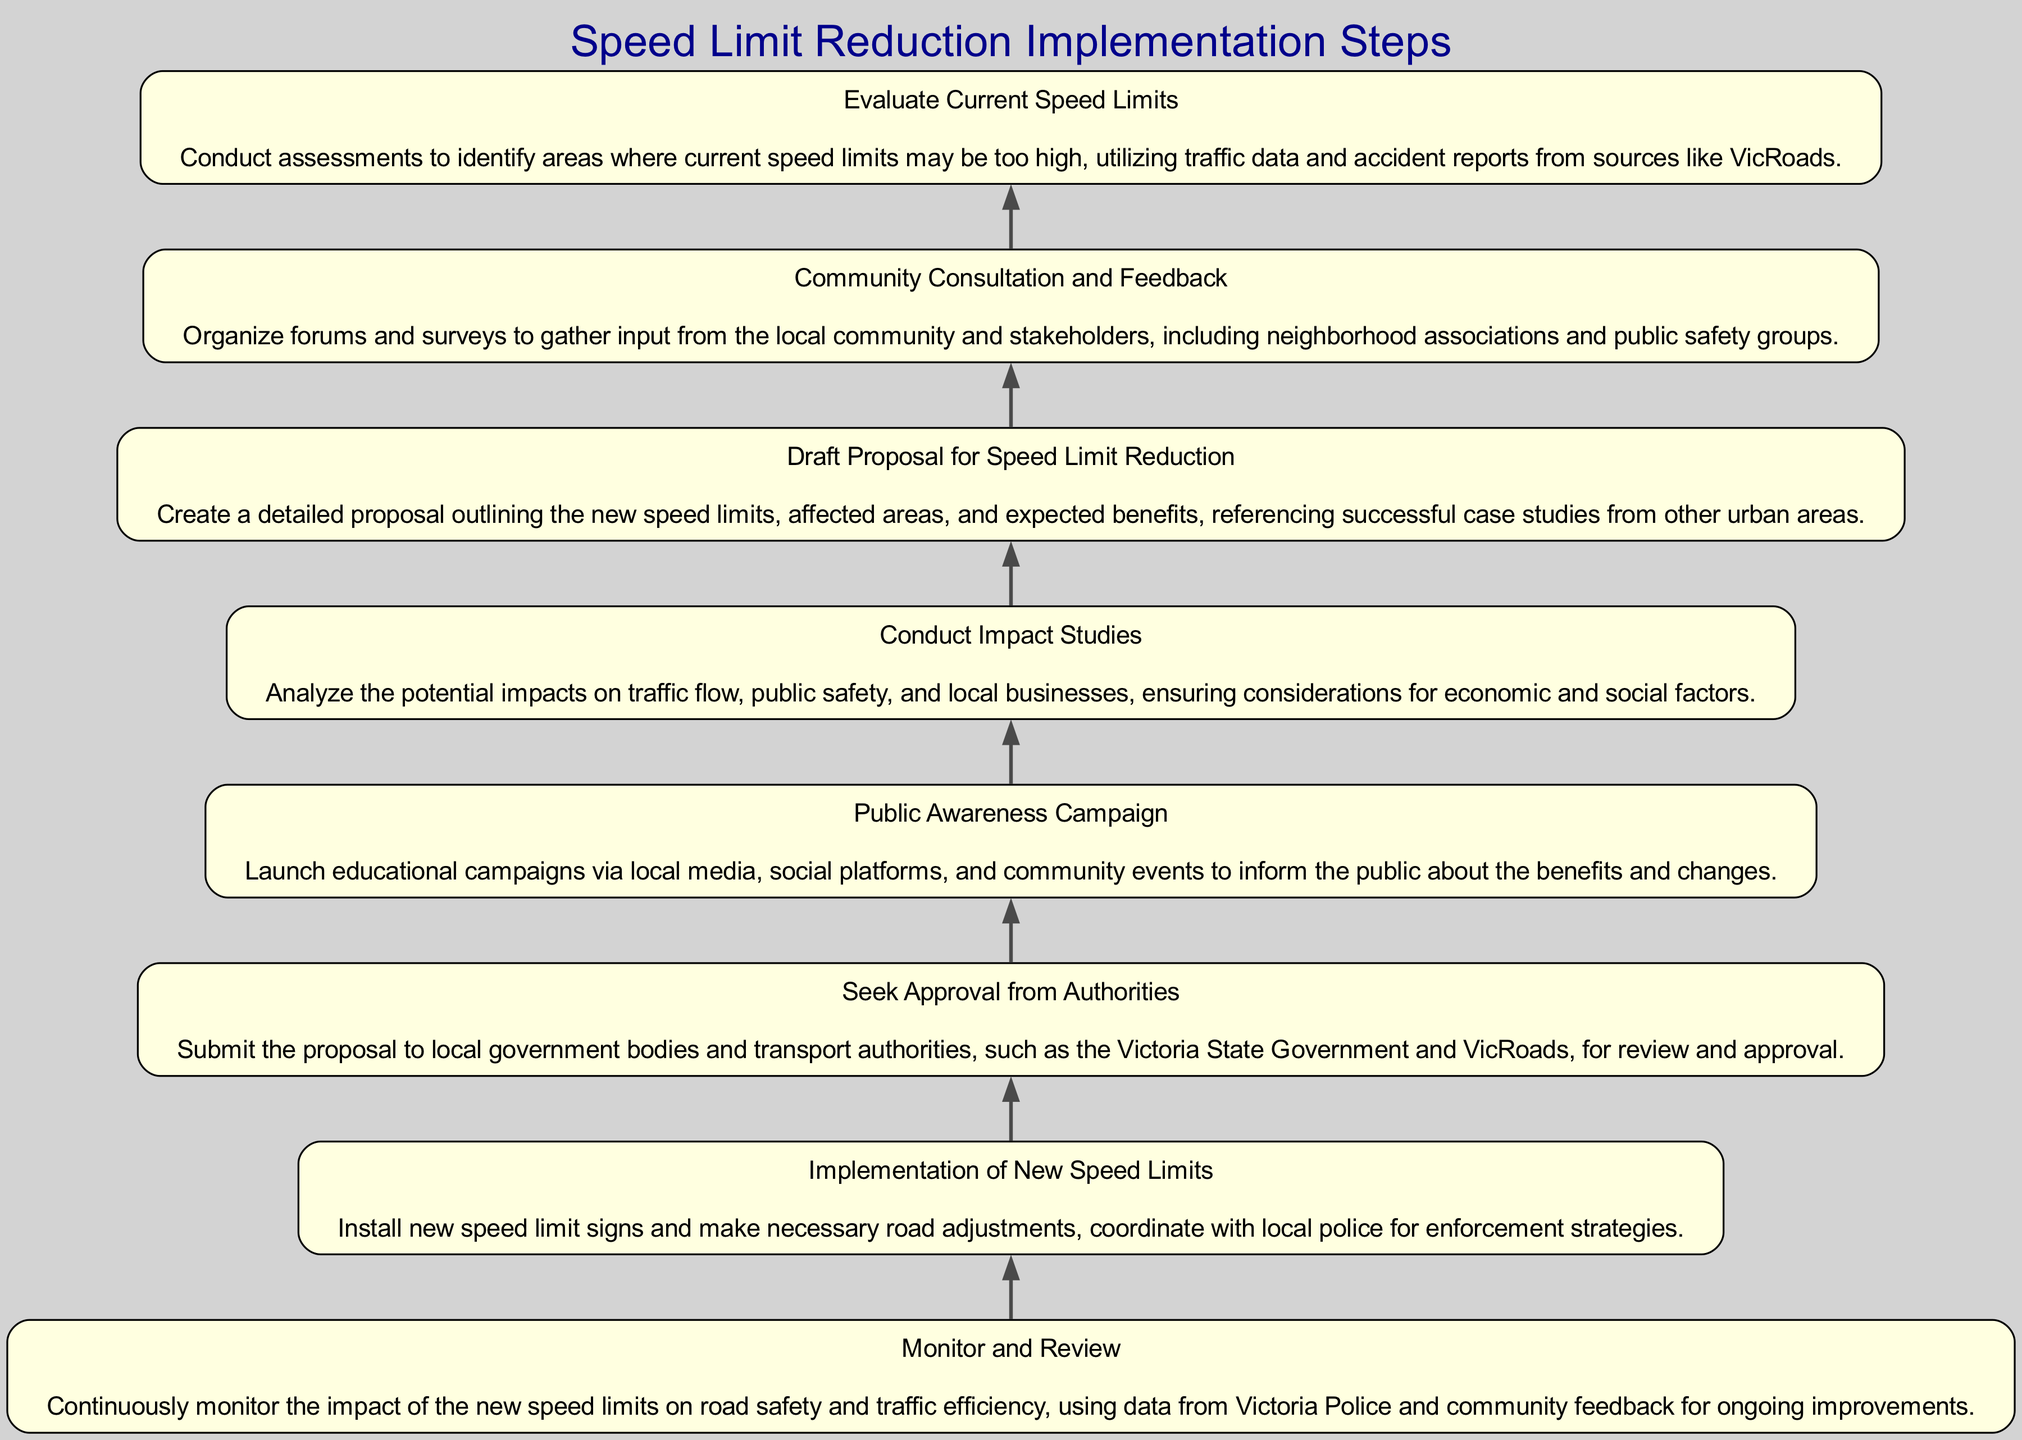What is the first step in the implementation process? The diagram indicates that the first step at the bottom is "Evaluate Current Speed Limits." Therefore, this is where the process begins to assess current speed regulations.
Answer: Evaluate Current Speed Limits How many total steps are there in the implementation flowchart? Counting each of the steps listed in the diagram, there are a total of eight steps involved in the speed limit reduction process.
Answer: Eight What is the last step in the flowchart? The flowchart concludes with the step "Monitor and Review," which is the final action to ensure the effectiveness of the new speed limits.
Answer: Monitor and Review Which step directly follows "Seek Approval from Authorities"? Following "Seek Approval from Authorities," the next step in the flowchart is "Implementation of New Speed Limits," marking the transition from proposal to action.
Answer: Implementation of New Speed Limits What step involves community input? The step titled "Community Consultation and Feedback" specifically addresses the need to gather input from the local community and stakeholders in the process.
Answer: Community Consultation and Feedback Which two steps focus on public engagement? The two steps that involve public engagement are "Community Consultation and Feedback" and "Public Awareness Campaign," both aimed at informing and involving the public.
Answer: Community Consultation and Feedback, Public Awareness Campaign What is the purpose of the "Conduct Impact Studies" step? This step serves to analyze the effects of the proposed speed limit reductions, particularly on traffic flow and public safety, ensuring a well-rounded understanding of potential outcomes.
Answer: Analyze potential impacts Which step discusses the proposal's submission for approval? The step related to submitting the proposal for approval is "Seek Approval from Authorities," where necessary authorities review the documented plan.
Answer: Seek Approval from Authorities 